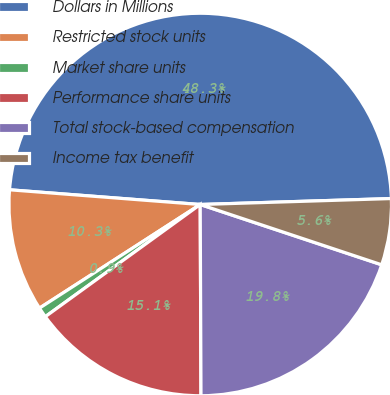<chart> <loc_0><loc_0><loc_500><loc_500><pie_chart><fcel>Dollars in Millions<fcel>Restricted stock units<fcel>Market share units<fcel>Performance share units<fcel>Total stock-based compensation<fcel>Income tax benefit<nl><fcel>48.28%<fcel>10.34%<fcel>0.86%<fcel>15.09%<fcel>19.83%<fcel>5.6%<nl></chart> 